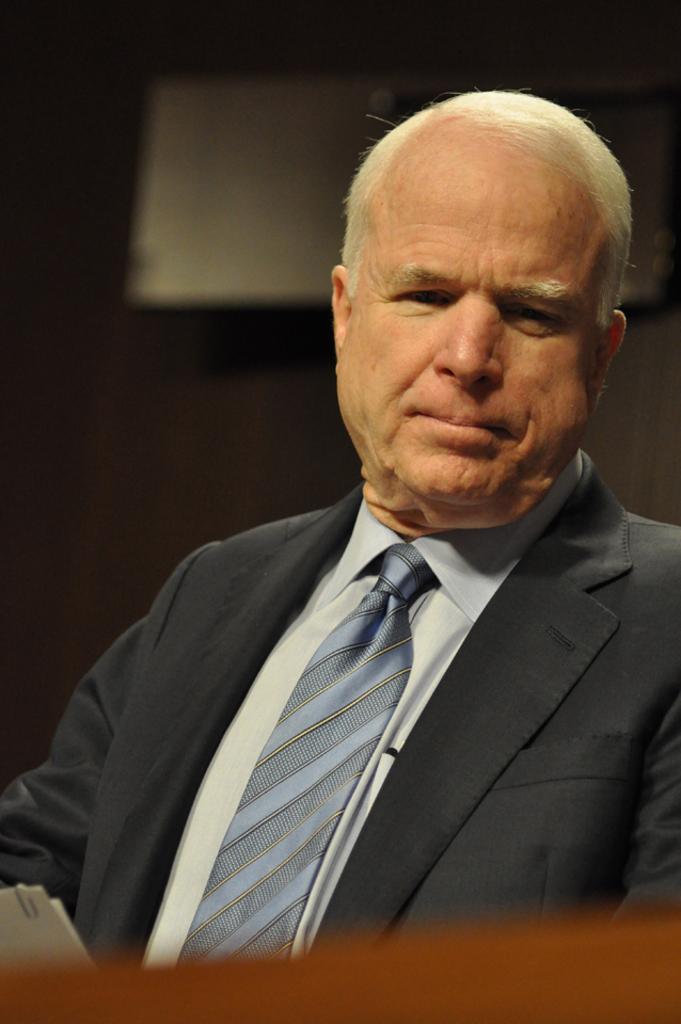Can you describe this image briefly? In this picture there is a man sitting. In the background of the image it is dark and we can see an object. 